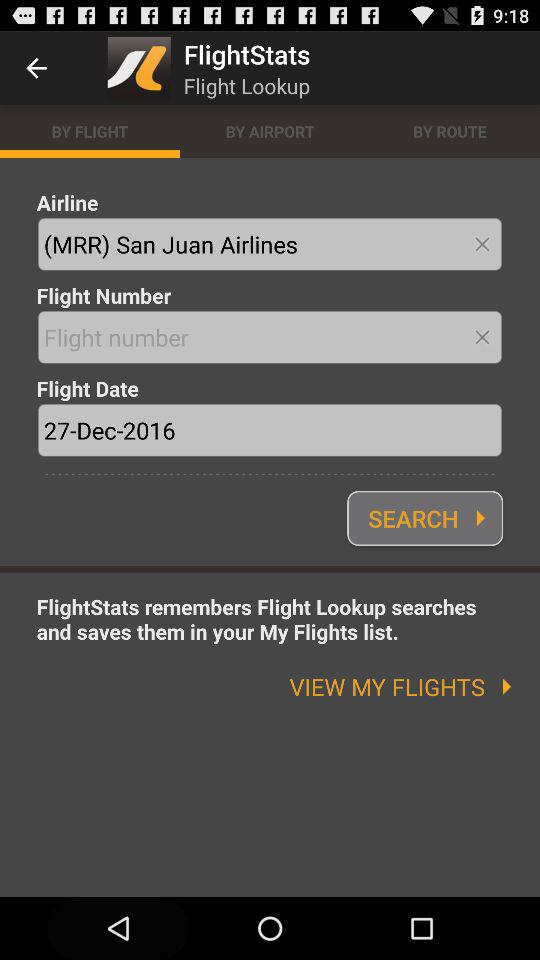What is the airline name? The airline name is San Juan Airlines. 